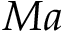<formula> <loc_0><loc_0><loc_500><loc_500>M a</formula> 